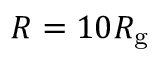Convert formula to latex. <formula><loc_0><loc_0><loc_500><loc_500>R = 1 0 R _ { g }</formula> 